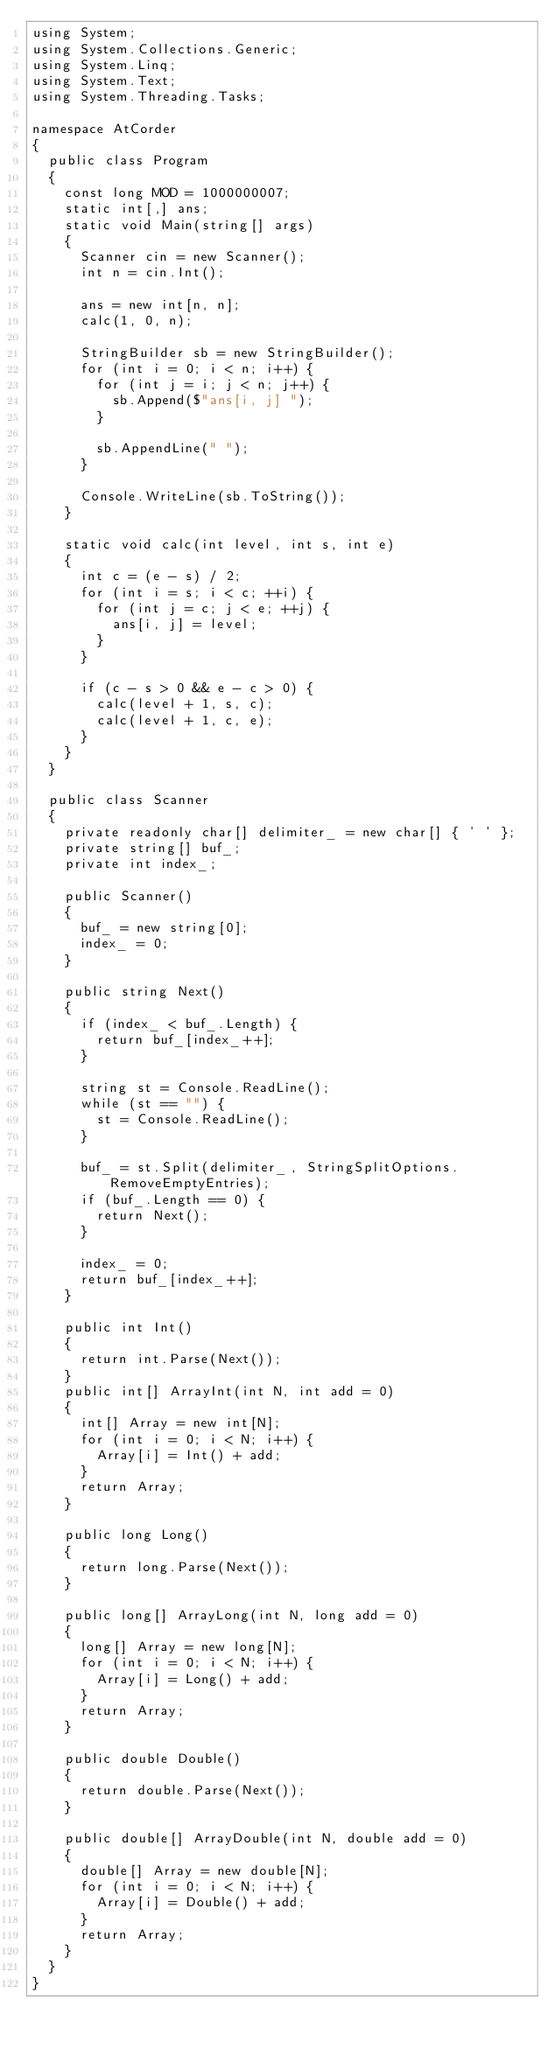<code> <loc_0><loc_0><loc_500><loc_500><_C#_>using System;
using System.Collections.Generic;
using System.Linq;
using System.Text;
using System.Threading.Tasks;

namespace AtCorder
{
	public class Program
	{
		const long MOD = 1000000007;
		static int[,] ans;
		static void Main(string[] args)
		{
			Scanner cin = new Scanner();
			int n = cin.Int();

			ans = new int[n, n];
			calc(1, 0, n);

			StringBuilder sb = new StringBuilder();
			for (int i = 0; i < n; i++) {
				for (int j = i; j < n; j++) {
					sb.Append($"ans[i, j] ");
				}

				sb.AppendLine(" ");
			}

			Console.WriteLine(sb.ToString());
		}

		static void calc(int level, int s, int e)
		{
			int c = (e - s) / 2;
			for (int i = s; i < c; ++i) {
				for (int j = c; j < e; ++j) {
					ans[i, j] = level;
				}
			}

			if (c - s > 0 && e - c > 0) {
				calc(level + 1, s, c);
				calc(level + 1, c, e);
			}
		}
	}

	public class Scanner
	{
		private readonly char[] delimiter_ = new char[] { ' ' };
		private string[] buf_;
		private int index_;

		public Scanner()
		{
			buf_ = new string[0];
			index_ = 0;
		}

		public string Next()
		{
			if (index_ < buf_.Length) {
				return buf_[index_++];
			}

			string st = Console.ReadLine();
			while (st == "") {
				st = Console.ReadLine();
			}

			buf_ = st.Split(delimiter_, StringSplitOptions.RemoveEmptyEntries);
			if (buf_.Length == 0) {
				return Next();
			}

			index_ = 0;
			return buf_[index_++];
		}

		public int Int()
		{
			return int.Parse(Next());
		}
		public int[] ArrayInt(int N, int add = 0)
		{
			int[] Array = new int[N];
			for (int i = 0; i < N; i++) {
				Array[i] = Int() + add;
			}
			return Array;
		}

		public long Long()
		{
			return long.Parse(Next());
		}

		public long[] ArrayLong(int N, long add = 0)
		{
			long[] Array = new long[N];
			for (int i = 0; i < N; i++) {
				Array[i] = Long() + add;
			}
			return Array;
		}

		public double Double()
		{
			return double.Parse(Next());
		}

		public double[] ArrayDouble(int N, double add = 0)
		{
			double[] Array = new double[N];
			for (int i = 0; i < N; i++) {
				Array[i] = Double() + add;
			}
			return Array;
		}
	}
}</code> 